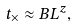Convert formula to latex. <formula><loc_0><loc_0><loc_500><loc_500>t _ { \times } \approx B L ^ { z } ,</formula> 